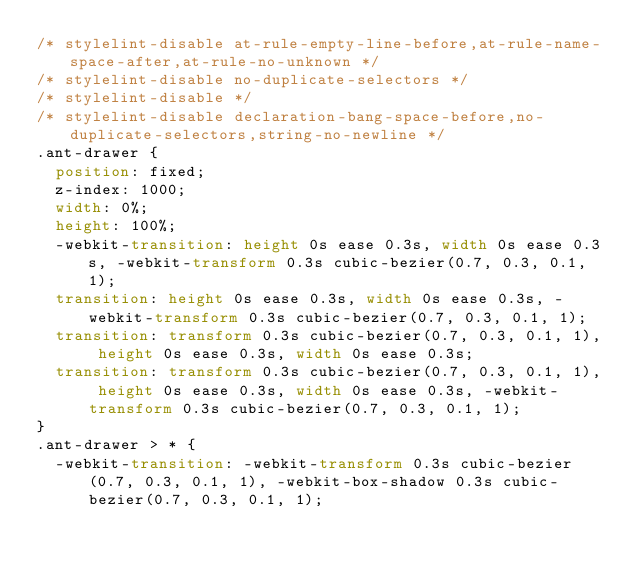Convert code to text. <code><loc_0><loc_0><loc_500><loc_500><_CSS_>/* stylelint-disable at-rule-empty-line-before,at-rule-name-space-after,at-rule-no-unknown */
/* stylelint-disable no-duplicate-selectors */
/* stylelint-disable */
/* stylelint-disable declaration-bang-space-before,no-duplicate-selectors,string-no-newline */
.ant-drawer {
  position: fixed;
  z-index: 1000;
  width: 0%;
  height: 100%;
  -webkit-transition: height 0s ease 0.3s, width 0s ease 0.3s, -webkit-transform 0.3s cubic-bezier(0.7, 0.3, 0.1, 1);
  transition: height 0s ease 0.3s, width 0s ease 0.3s, -webkit-transform 0.3s cubic-bezier(0.7, 0.3, 0.1, 1);
  transition: transform 0.3s cubic-bezier(0.7, 0.3, 0.1, 1), height 0s ease 0.3s, width 0s ease 0.3s;
  transition: transform 0.3s cubic-bezier(0.7, 0.3, 0.1, 1), height 0s ease 0.3s, width 0s ease 0.3s, -webkit-transform 0.3s cubic-bezier(0.7, 0.3, 0.1, 1);
}
.ant-drawer > * {
  -webkit-transition: -webkit-transform 0.3s cubic-bezier(0.7, 0.3, 0.1, 1), -webkit-box-shadow 0.3s cubic-bezier(0.7, 0.3, 0.1, 1);</code> 